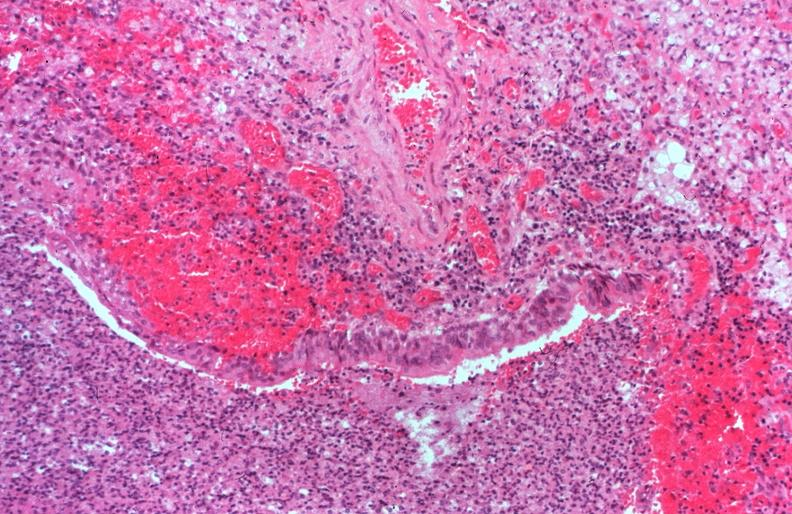what is present?
Answer the question using a single word or phrase. Respiratory 